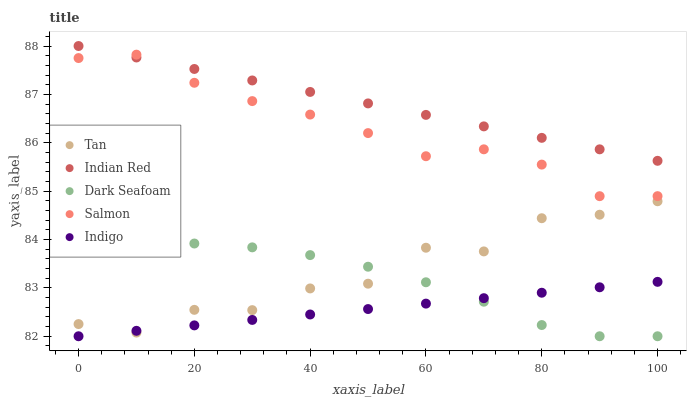Does Indigo have the minimum area under the curve?
Answer yes or no. Yes. Does Indian Red have the maximum area under the curve?
Answer yes or no. Yes. Does Tan have the minimum area under the curve?
Answer yes or no. No. Does Tan have the maximum area under the curve?
Answer yes or no. No. Is Indian Red the smoothest?
Answer yes or no. Yes. Is Tan the roughest?
Answer yes or no. Yes. Is Salmon the smoothest?
Answer yes or no. No. Is Salmon the roughest?
Answer yes or no. No. Does Indigo have the lowest value?
Answer yes or no. Yes. Does Tan have the lowest value?
Answer yes or no. No. Does Indian Red have the highest value?
Answer yes or no. Yes. Does Tan have the highest value?
Answer yes or no. No. Is Dark Seafoam less than Salmon?
Answer yes or no. Yes. Is Salmon greater than Tan?
Answer yes or no. Yes. Does Salmon intersect Indian Red?
Answer yes or no. Yes. Is Salmon less than Indian Red?
Answer yes or no. No. Is Salmon greater than Indian Red?
Answer yes or no. No. Does Dark Seafoam intersect Salmon?
Answer yes or no. No. 